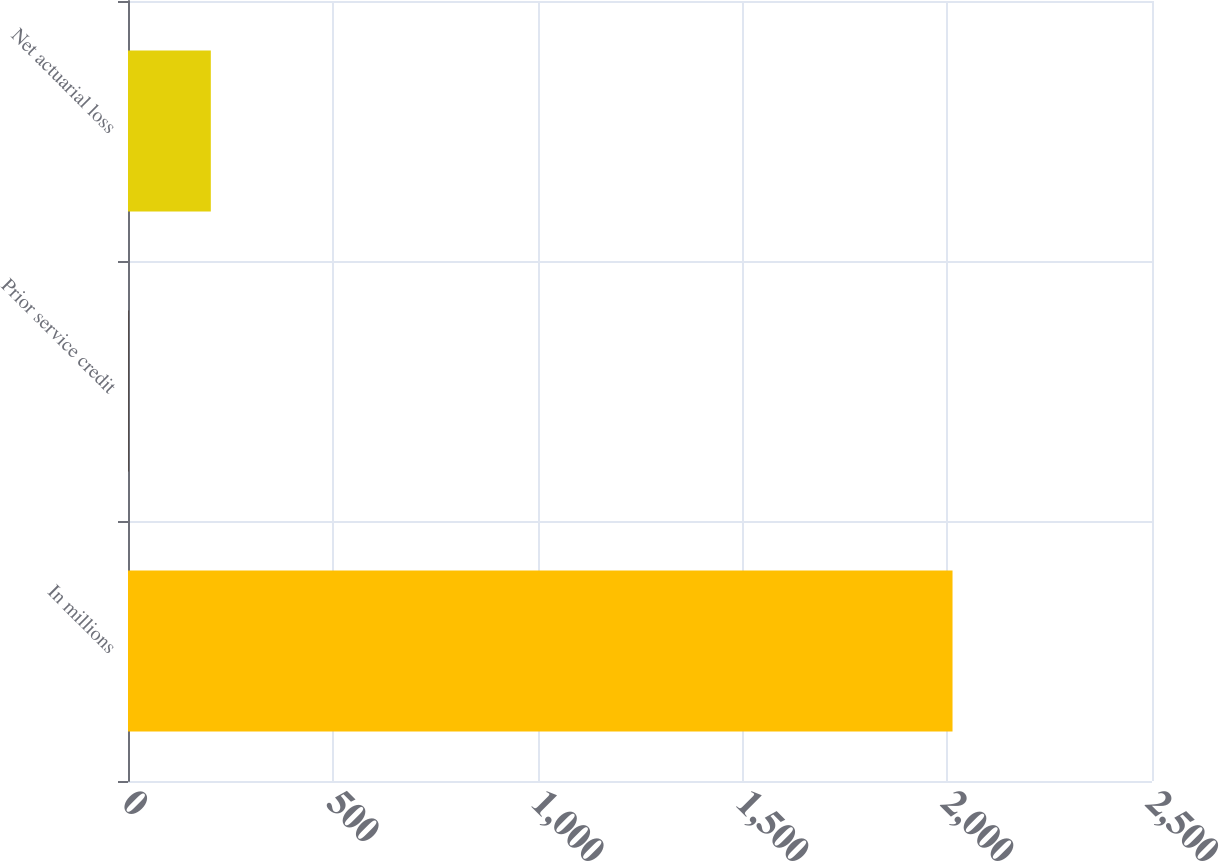Convert chart to OTSL. <chart><loc_0><loc_0><loc_500><loc_500><bar_chart><fcel>In millions<fcel>Prior service credit<fcel>Net actuarial loss<nl><fcel>2013<fcel>1<fcel>202.2<nl></chart> 